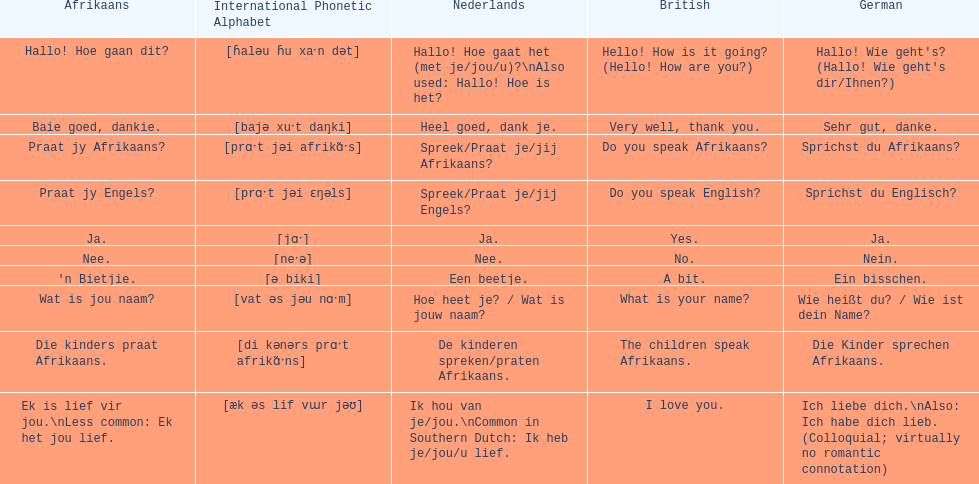How do you say "do you speak afrikaans?" in afrikaans? Praat jy Afrikaans?. 